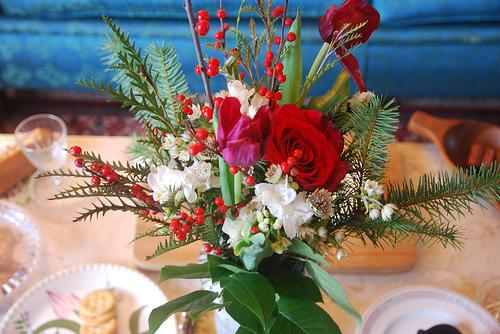Identify the color of the wall and the table cloth. The wall is blue, and the table cloth is white. Describe the plate that has crackers on it. The plate with crackers is white, circular, and has a pattern. Identify any objects that could be associated with a Christmas theme. Cranberries, holly beads, and branches that look like a Christmas tree are objects associated with a Christmas theme. What type of object is the cutting board made of? The cutting board is made of wood. State the color and location of the wine glass. The wine glass is clear and located on the table. What types of flowers are mentioned in the image descriptions? Roses, carnations, and white flowers are mentioned in the image descriptions. What objects have red color in the image? Roses, cranberries, cherries, and red items by the rose all have red color in the image. What is the sentiment of the image considering the objects and their arrangement? The sentiment of the image is festive and elegant, with a floral centerpiece, crackers, and a wine glass on a table. What are the primary events happening in the image? A floral centerpiece arrangement is on a table, with crackers on a plate and a wine glass beside it. Count the total number of food items mentioned in the image. There are three food items mentioned: crackers, biscuits, and cranberries. Is the table cloth blue in color? The table cloth is mentioned as white in color, not blue. What type of glassware is on the table? A clear wine goblet Can you find the yellow carnations in the image? There are no yellow carnations mentioned in the image, only white carnations are present. Which flower is red in the arrangement? b) Lily What type of event does the table setting depict? A stylish and elegant breakfast or brunch event Identify the color of the background wall and list any text or patterns present. The wall is blue and there are no patterns or text. There is a plate with food offerings, identify the food item(s) on the plate. Crackers Describe the emotional expression of an individual in the image, if any. There are no individuals in the image. Is the cutting board made of wood, plastic, or marble? Wood What color is the table cloth? White What is present on the table besides flowers? A plate with crackers, a wooden bowl, a wine glass, and a patterned tablecloth. What type of flowers are white in the image? Carnations Can you spot a square plate on the table? The plates in the image are described as circular, not square. Create a short story that takes place at this table setting. It was a quiet morning, and the table was set for a simple yet elegant breakfast. Beautiful red roses, white carnations, and vibrant green leaves decorated the centerpiece. Beside the flowers lay a plate, adorned with a single row of crackers, and a wooden bowl waiting to be filled with fruits. A wine glass sparkled nearby, hinting at the desire for a fine meal. Surrounded by a blue wall and a white tablecloth, this scene was the perfect setting for a romantic breakfast between two lovers. What is the main object in the center of the image? A floral centerpiece Are there any purple roses in the flower arrangement? The roses in the image are only mentioned as being red, not purple. What type of berries are in the vase? b) Raspberries Are there any cookies on the table? There are no cookies mentioned in the image, only crackers. List the objects found inside the vase. Red roses, white carnations, green leaves, and cranberries. List the arrangement of flowers on the table. There is a vase containing an arrangement of red roses, white carnations, green leaves, and cranberries. What types of flowers are found in the centerpiece? Red roses and white carnations Is there any decoration in the wine glass? No, there is no decoration in the wine glass. Examine the diagram and determine the type of diagram it represents. There is no diagram in the image. Is the wall in the background pink in color? The wall in the background is described as blue, not pink. What is the color of the leaves in the image? Green 